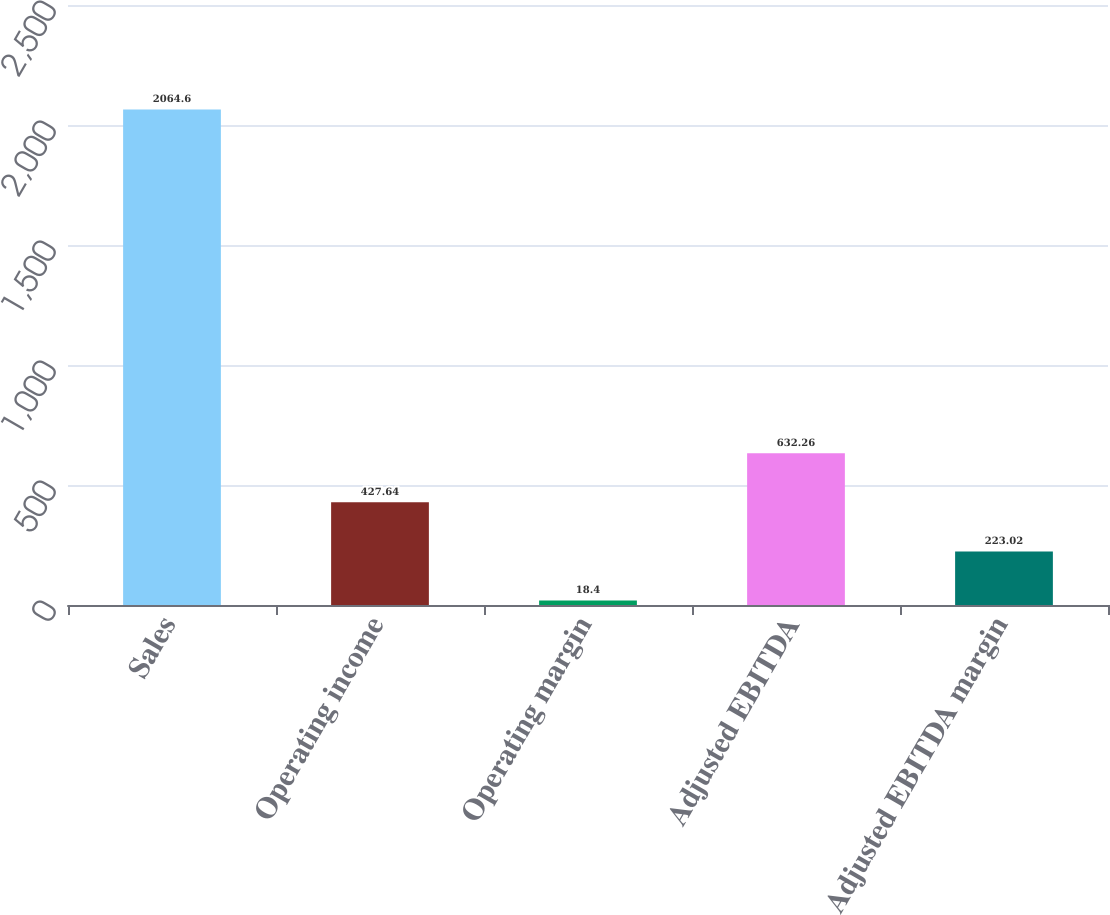<chart> <loc_0><loc_0><loc_500><loc_500><bar_chart><fcel>Sales<fcel>Operating income<fcel>Operating margin<fcel>Adjusted EBITDA<fcel>Adjusted EBITDA margin<nl><fcel>2064.6<fcel>427.64<fcel>18.4<fcel>632.26<fcel>223.02<nl></chart> 